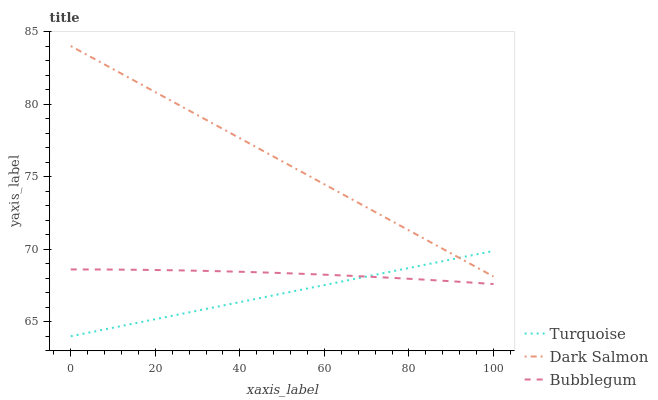Does Turquoise have the minimum area under the curve?
Answer yes or no. Yes. Does Dark Salmon have the maximum area under the curve?
Answer yes or no. Yes. Does Bubblegum have the minimum area under the curve?
Answer yes or no. No. Does Bubblegum have the maximum area under the curve?
Answer yes or no. No. Is Dark Salmon the smoothest?
Answer yes or no. Yes. Is Bubblegum the roughest?
Answer yes or no. Yes. Is Bubblegum the smoothest?
Answer yes or no. No. Is Dark Salmon the roughest?
Answer yes or no. No. Does Turquoise have the lowest value?
Answer yes or no. Yes. Does Bubblegum have the lowest value?
Answer yes or no. No. Does Dark Salmon have the highest value?
Answer yes or no. Yes. Does Bubblegum have the highest value?
Answer yes or no. No. Is Bubblegum less than Dark Salmon?
Answer yes or no. Yes. Is Dark Salmon greater than Bubblegum?
Answer yes or no. Yes. Does Turquoise intersect Dark Salmon?
Answer yes or no. Yes. Is Turquoise less than Dark Salmon?
Answer yes or no. No. Is Turquoise greater than Dark Salmon?
Answer yes or no. No. Does Bubblegum intersect Dark Salmon?
Answer yes or no. No. 